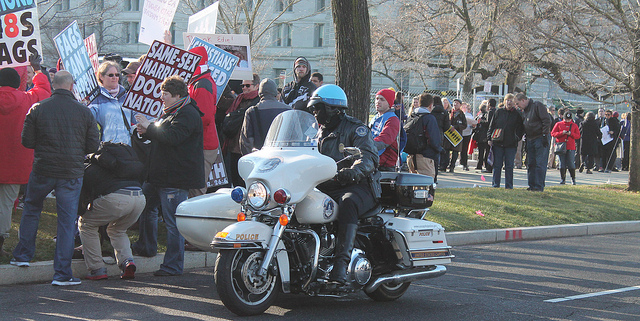Extract all visible text content from this image. SAME SEX NATION MARR AGS 8S CANT FAGS H ED TIANS DOC 